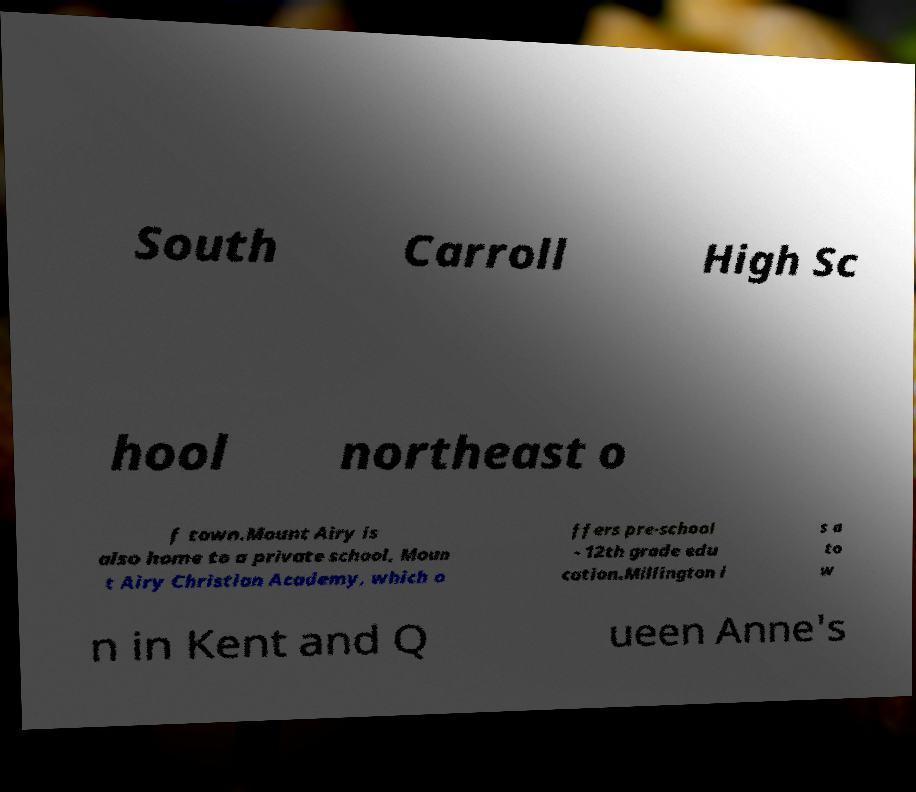Could you extract and type out the text from this image? South Carroll High Sc hool northeast o f town.Mount Airy is also home to a private school, Moun t Airy Christian Academy, which o ffers pre-school - 12th grade edu cation.Millington i s a to w n in Kent and Q ueen Anne's 